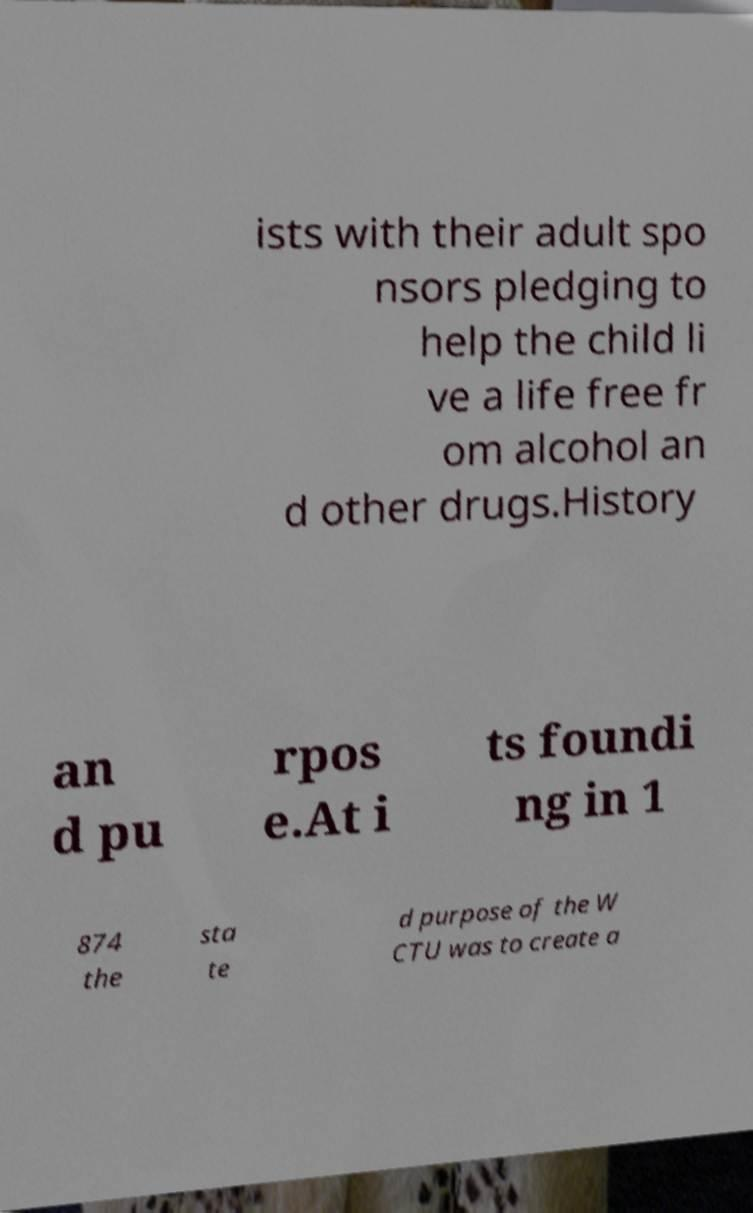Can you read and provide the text displayed in the image?This photo seems to have some interesting text. Can you extract and type it out for me? ists with their adult spo nsors pledging to help the child li ve a life free fr om alcohol an d other drugs.History an d pu rpos e.At i ts foundi ng in 1 874 the sta te d purpose of the W CTU was to create a 